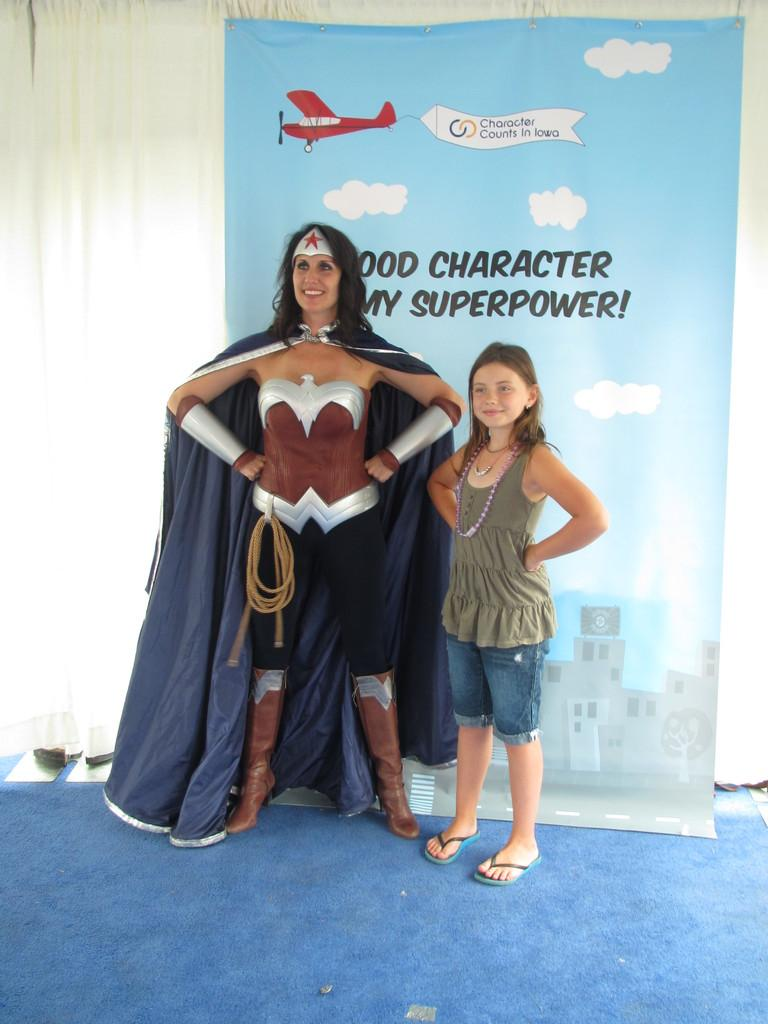<image>
Offer a succinct explanation of the picture presented. A girl stands next to a woman in a superhero costume in front of a sign that says "Good Character Is My Superpower". 